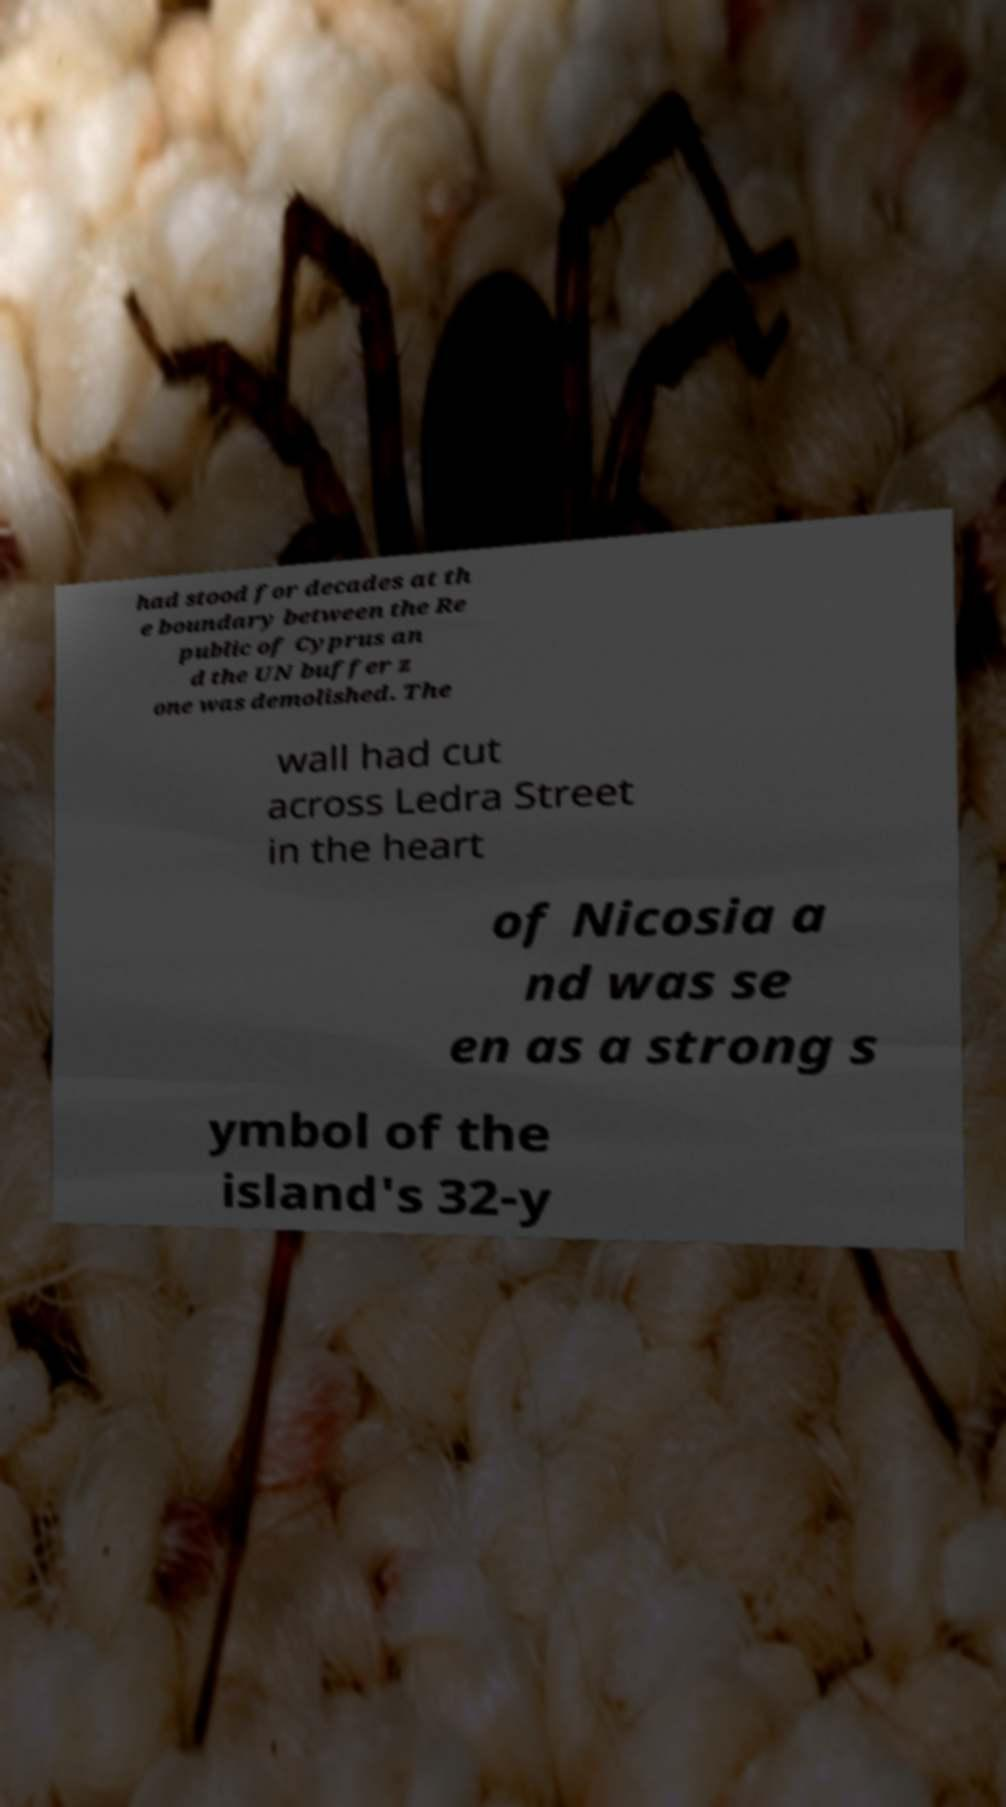Can you accurately transcribe the text from the provided image for me? had stood for decades at th e boundary between the Re public of Cyprus an d the UN buffer z one was demolished. The wall had cut across Ledra Street in the heart of Nicosia a nd was se en as a strong s ymbol of the island's 32-y 